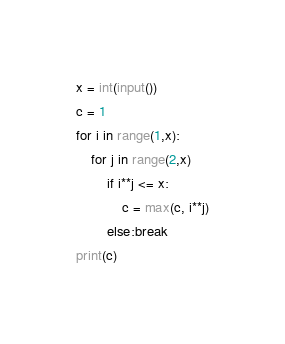Convert code to text. <code><loc_0><loc_0><loc_500><loc_500><_Python_>x = int(input())
c = 1
for i in range(1,x):
    for j in range(2,x)
        if i**j <= x:
            c = max(c, i**j)
        else:break
print(c)</code> 